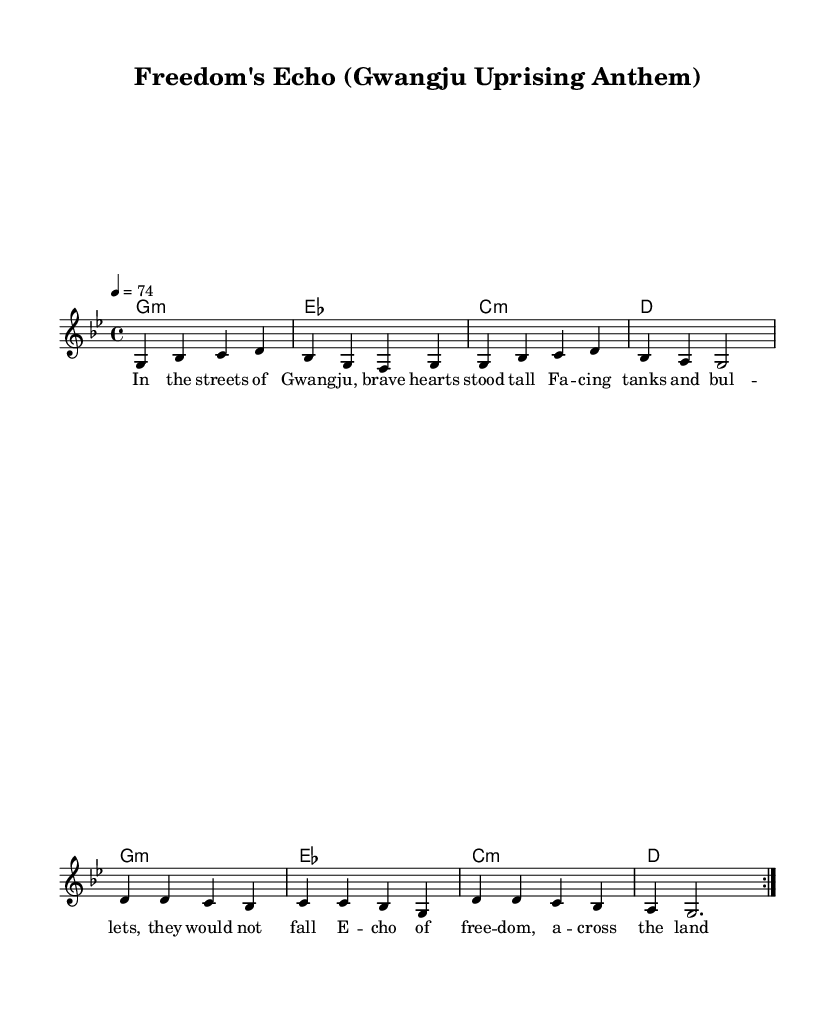What is the key signature of this music? The key signature is G minor, indicated by the one flat that is present on the staff.
Answer: G minor What is the time signature of this music? The time signature is 4/4, shown in the beginning of the score where the two numbers are placed.
Answer: 4/4 What is the tempo marking of this music? The tempo marking is 74 beats per minute, indicated in the score as a tempo instruction at the top.
Answer: 74 How many measures are in the repeated section? The repeated section contains eight measures, as noted by the volta indication suggesting the section repeats, and we see eight measures total within the repeated section.
Answer: 8 Which two historical figures are celebrated in the lyrics? The lyrics do not mention specific historical figures but refer to the general concept of "heroes" from the Gwangju uprising. They represent the collective struggle for democracy.
Answer: Heroes What genre does this piece belong to? The piece is categorized as Reggae, characterized by its offbeat rhythm and the lyrical content that reflects social and political themes, aligning with the essence of Reggae music.
Answer: Reggae 